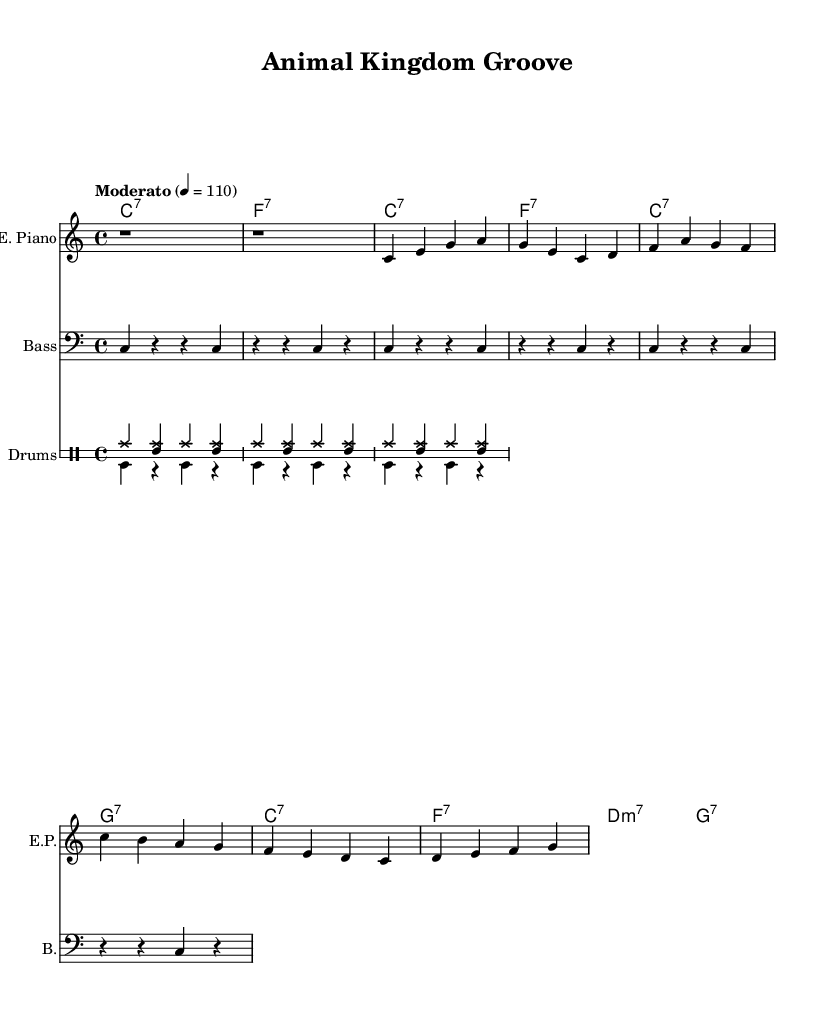What is the key signature of this music? The key signature is specified in the global section as C major, which has no sharps or flats.
Answer: C major What is the time signature of the piece? The time signature is indicated in the global section as 4/4, which means there are four beats in each measure and the quarter note gets one beat.
Answer: 4/4 What is the tempo marking given for the song? The tempo marking in the global section indicates "Moderato" with a metronome marking of quarter note = 110, which guides the speed of the piece.
Answer: Moderato, 110 How many measures are in the verse section? By analyzing the provided electric piano and bass sections, there are four measures identified under "Verse 1," each composing a distinct segment.
Answer: 4 What animal characteristics are described in the lyrics? The lyrics reference the spots of a cheetah and the grace of a leopard, as well as the long neck that extends into space of a giraffe, which highlights unique traits of these animals.
Answer: Cheetah's spots, leopard's grace, giraffe's neck How many instruments are included in the score? The score outlines four distinct groups: electric piano, bass guitar, and two drum voices, totaling four instrumental sections.
Answer: 4 What chord progression appears in the chorus? The chord progression in the chorus section is C major 7 to F major 7, followed by D minor 7 to G major 7, demonstrating a common soul music structure of tonal stability.
Answer: C major 7, F major 7, D minor 7, G major 7 